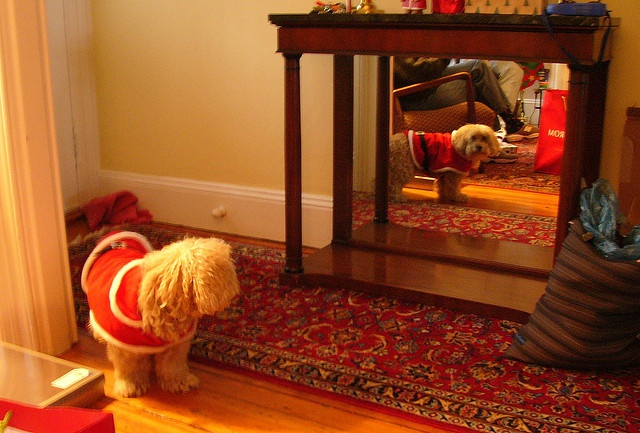Describe the objects in this image and their specific colors. I can see dog in orange, red, maroon, and brown tones, handbag in orange, black, maroon, and brown tones, chair in orange, maroon, black, and brown tones, people in orange, black, maroon, and brown tones, and people in orange, olive, maroon, and tan tones in this image. 